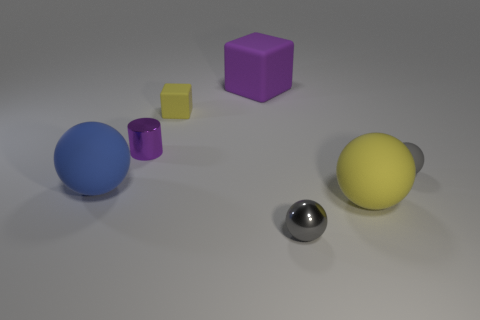What shape is the tiny metal object that is behind the tiny metallic object that is on the right side of the tiny cylinder?
Provide a succinct answer. Cylinder. There is a gray metal thing that is the same size as the yellow rubber cube; what is its shape?
Offer a very short reply. Sphere. Is there another yellow thing of the same shape as the big yellow thing?
Provide a short and direct response. No. What is the material of the small yellow object?
Provide a succinct answer. Rubber. Are there any cubes in front of the purple matte object?
Your answer should be very brief. Yes. There is a large object that is to the right of the metal ball; what number of rubber cubes are right of it?
Keep it short and to the point. 0. What is the material of the yellow object that is the same size as the metallic ball?
Provide a succinct answer. Rubber. How many other objects are the same material as the small yellow object?
Provide a succinct answer. 4. What number of gray rubber balls are behind the yellow matte block?
Offer a terse response. 0. What number of spheres are either big objects or small purple shiny objects?
Offer a terse response. 2. 